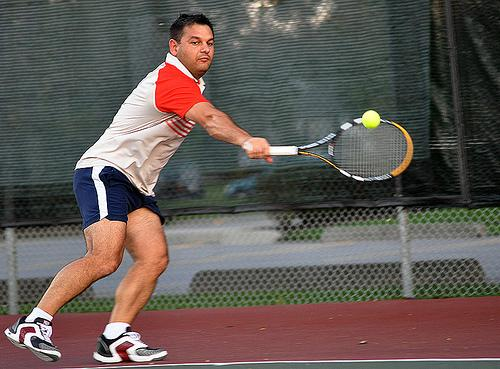Mention the key elements of the image, focusing on the player and his equipment. A man with dark hair is playing tennis, holding a racket with a white grip, while wearing blue shorts, a red and white shirt, white socks, and multicolored shoes. Talk about the tennis player's appearance and what he is wearing. The man has short dark hair and is wearing a red and white polo shirt, blue athletic shorts with a white stripe, white socks, and multicolored sneakers. Elaborate on the scene's setting and the main subject's appearance in the image. On a tennis court with green and red surfaces, a determined man with short, dark hair is playing tennis. He's dressed in a red and white polo shirt, blue athletic shorts, white socks, and vibrant sneakers. Offer a brief narrative of the tennis player's actions and energy in the image. In this dynamic image, a passionate tennis player with short dark hair is engaged in fierce competition, skillfully swinging his racket to strike the ball. Highlight the details of the tennis racket and the grip in the image. The tennis racket is large and about to hit the ball, featuring a white grip that the man is holding firmly. Discuss the presence of other objects in the image besides the tennis player, his equipment, and the court. There is a teal vehicle in the background and a green mesh fence behind the tennis player, as well as a couple of round yellow tennis balls on the court. Describe the situation involving the tennis ball and racket in the image. The tennis racket is about to make contact with a green tennis ball that is in mid-air, while another round yellow ball is nearby. Provide a concise description of the tennis court and its surroundings. The tennis court has a red surface and a green surface, with a green mesh fence hanging from the fence, and a teal vehicle in the background. Identify the primary action taking place in the image and provide a brief description. A Hispanic man with short dark hair is playing tennis, swinging his racket to hit a green ball in mid-air. Write about how the tennis player appears to be playing in the image. The man is in the midst of an intense tennis match, swinging his racket with determination to strike the airborne green tennis ball. 